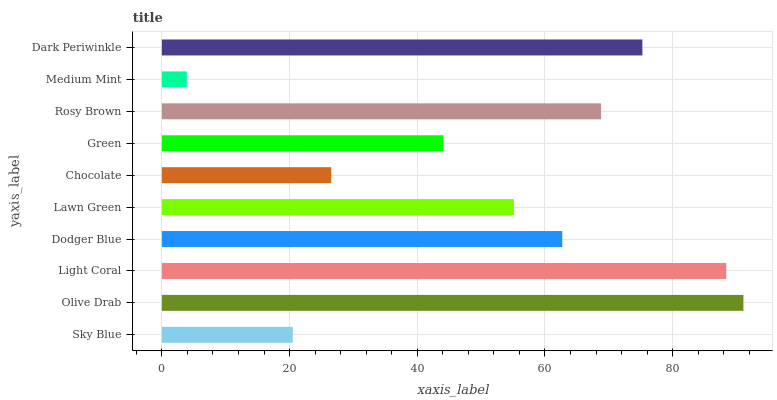Is Medium Mint the minimum?
Answer yes or no. Yes. Is Olive Drab the maximum?
Answer yes or no. Yes. Is Light Coral the minimum?
Answer yes or no. No. Is Light Coral the maximum?
Answer yes or no. No. Is Olive Drab greater than Light Coral?
Answer yes or no. Yes. Is Light Coral less than Olive Drab?
Answer yes or no. Yes. Is Light Coral greater than Olive Drab?
Answer yes or no. No. Is Olive Drab less than Light Coral?
Answer yes or no. No. Is Dodger Blue the high median?
Answer yes or no. Yes. Is Lawn Green the low median?
Answer yes or no. Yes. Is Sky Blue the high median?
Answer yes or no. No. Is Chocolate the low median?
Answer yes or no. No. 